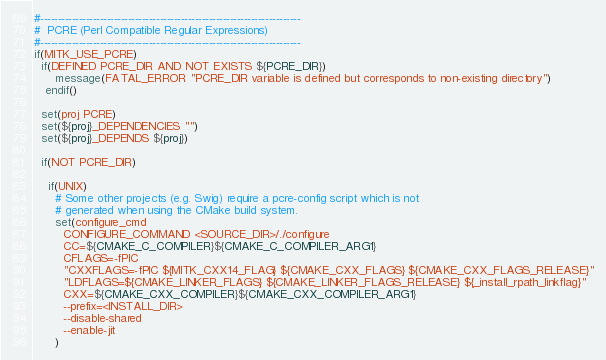Convert code to text. <code><loc_0><loc_0><loc_500><loc_500><_CMake_>#--------------------------------------------------------------------------
#  PCRE (Perl Compatible Regular Expressions)
#--------------------------------------------------------------------------
if(MITK_USE_PCRE)
  if(DEFINED PCRE_DIR AND NOT EXISTS ${PCRE_DIR})
      message(FATAL_ERROR "PCRE_DIR variable is defined but corresponds to non-existing directory")
   endif()

  set(proj PCRE)
  set(${proj}_DEPENDENCIES "")
  set(${proj}_DEPENDS ${proj})

  if(NOT PCRE_DIR)

    if(UNIX)
      # Some other projects (e.g. Swig) require a pcre-config script which is not
      # generated when using the CMake build system.
      set(configure_cmd
        CONFIGURE_COMMAND <SOURCE_DIR>/./configure
        CC=${CMAKE_C_COMPILER}${CMAKE_C_COMPILER_ARG1}
        CFLAGS=-fPIC
        "CXXFLAGS=-fPIC ${MITK_CXX14_FLAG} ${CMAKE_CXX_FLAGS} ${CMAKE_CXX_FLAGS_RELEASE}"
        "LDFLAGS=${CMAKE_LINKER_FLAGS} ${CMAKE_LINKER_FLAGS_RELEASE} ${_install_rpath_linkflag}"
        CXX=${CMAKE_CXX_COMPILER}${CMAKE_CXX_COMPILER_ARG1}
        --prefix=<INSTALL_DIR>
        --disable-shared
        --enable-jit
      )</code> 